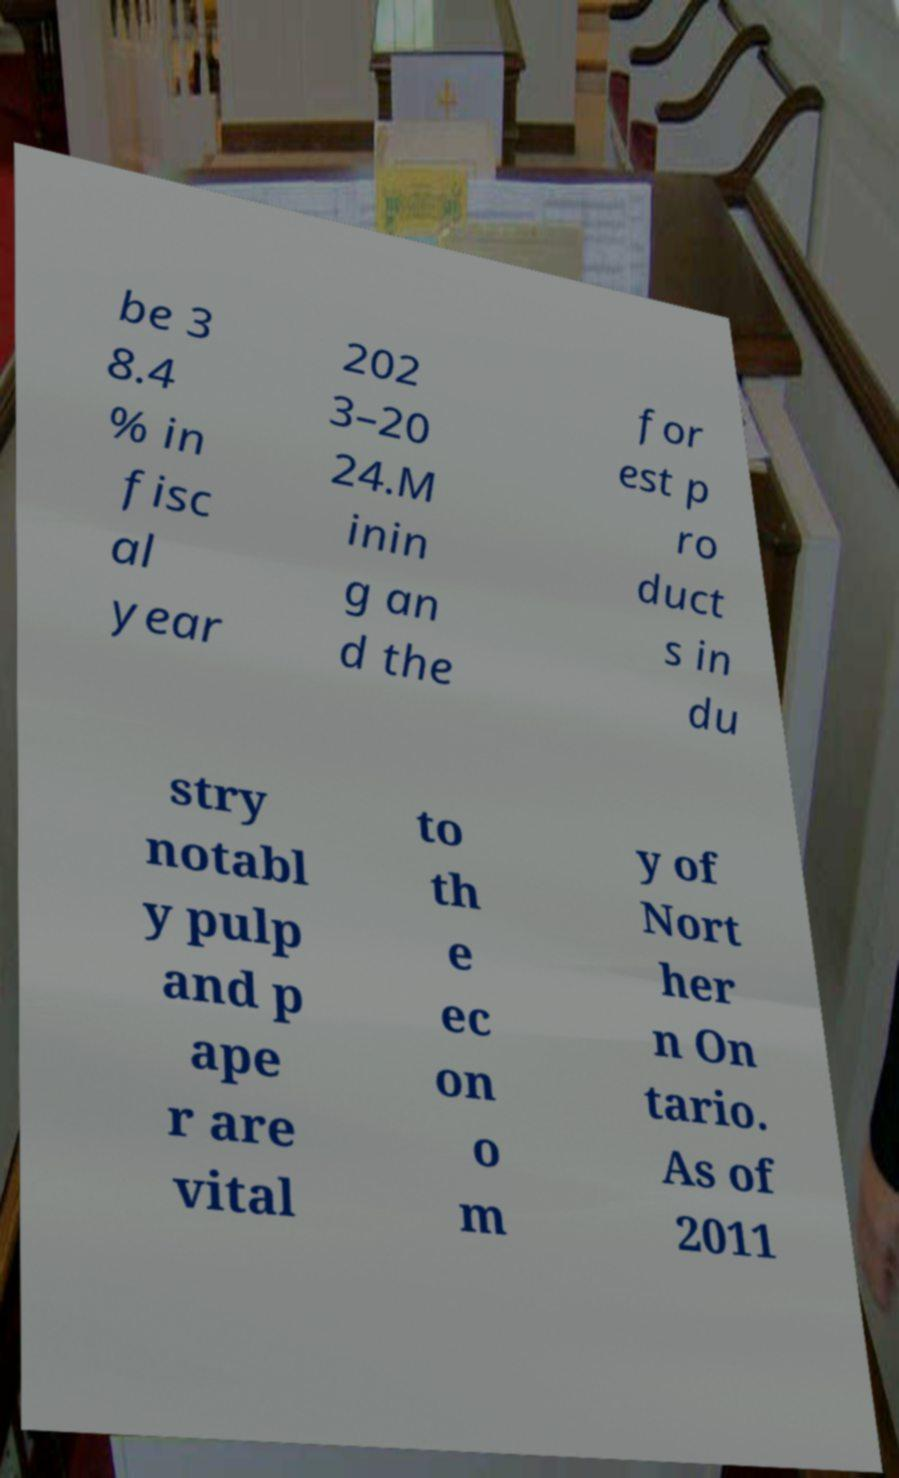Could you extract and type out the text from this image? be 3 8.4 % in fisc al year 202 3–20 24.M inin g an d the for est p ro duct s in du stry notabl y pulp and p ape r are vital to th e ec on o m y of Nort her n On tario. As of 2011 